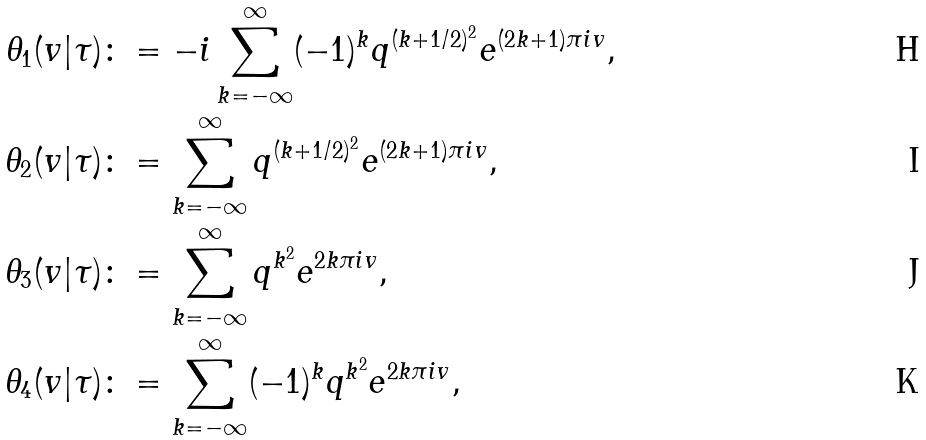Convert formula to latex. <formula><loc_0><loc_0><loc_500><loc_500>\theta _ { 1 } ( v | \tau ) & \colon = - i \sum _ { k = - \infty } ^ { \infty } ( - 1 ) ^ { k } q ^ { ( k + 1 / 2 ) ^ { 2 } } e ^ { ( 2 k + 1 ) \pi i v } , \\ \theta _ { 2 } ( v | \tau ) & \colon = \sum _ { k = - \infty } ^ { \infty } q ^ { ( k + 1 / 2 ) ^ { 2 } } e ^ { ( 2 k + 1 ) \pi i v } , \\ \theta _ { 3 } ( v | \tau ) & \colon = \sum _ { k = - \infty } ^ { \infty } q ^ { k ^ { 2 } } e ^ { 2 k \pi i v } , \\ \theta _ { 4 } ( v | \tau ) & \colon = \sum _ { k = - \infty } ^ { \infty } ( - 1 ) ^ { k } q ^ { k ^ { 2 } } e ^ { 2 k \pi i v } ,</formula> 